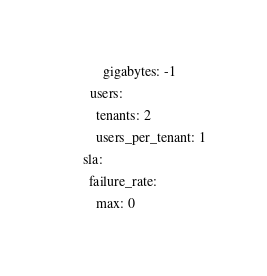<code> <loc_0><loc_0><loc_500><loc_500><_YAML_>            gigabytes: -1
        users:
          tenants: 2
          users_per_tenant: 1
      sla:
        failure_rate:
          max: 0
</code> 